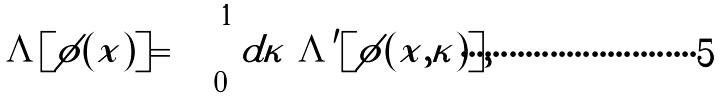<formula> <loc_0><loc_0><loc_500><loc_500>\Lambda [ \phi ( x ) ] = \int _ { 0 } ^ { 1 } d \kappa \ \Lambda ^ { \prime } [ \phi ( x , \kappa ) ] ,</formula> 